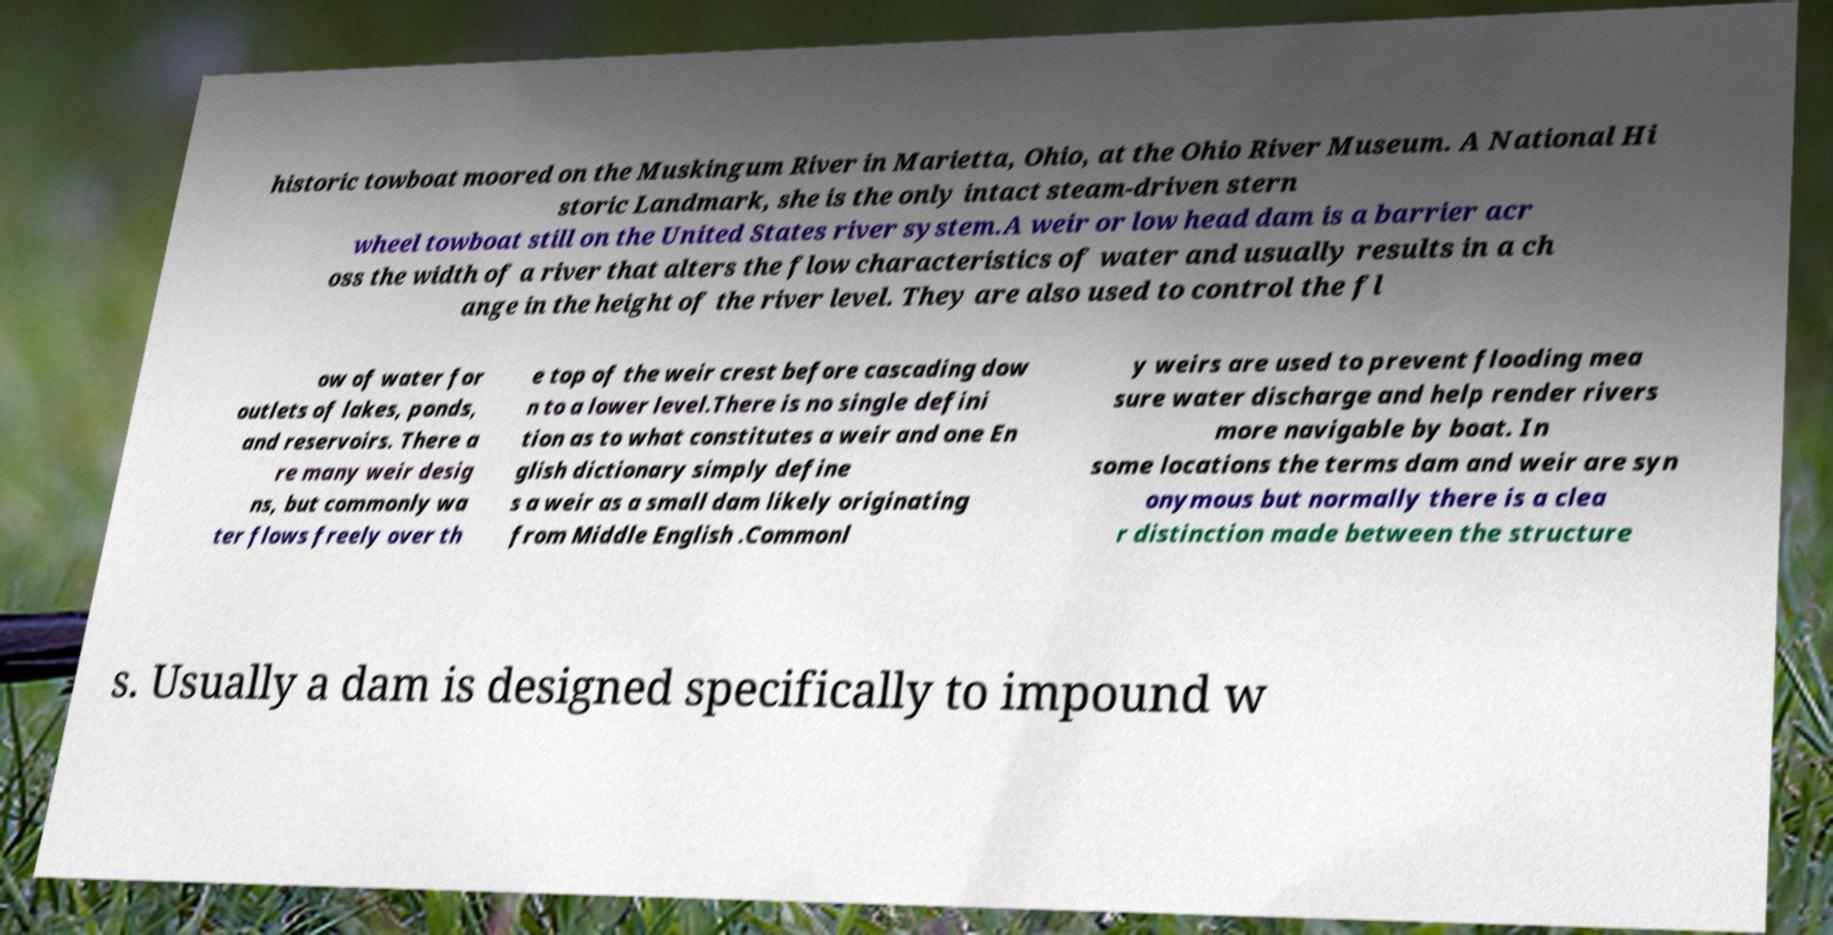I need the written content from this picture converted into text. Can you do that? historic towboat moored on the Muskingum River in Marietta, Ohio, at the Ohio River Museum. A National Hi storic Landmark, she is the only intact steam-driven stern wheel towboat still on the United States river system.A weir or low head dam is a barrier acr oss the width of a river that alters the flow characteristics of water and usually results in a ch ange in the height of the river level. They are also used to control the fl ow of water for outlets of lakes, ponds, and reservoirs. There a re many weir desig ns, but commonly wa ter flows freely over th e top of the weir crest before cascading dow n to a lower level.There is no single defini tion as to what constitutes a weir and one En glish dictionary simply define s a weir as a small dam likely originating from Middle English .Commonl y weirs are used to prevent flooding mea sure water discharge and help render rivers more navigable by boat. In some locations the terms dam and weir are syn onymous but normally there is a clea r distinction made between the structure s. Usually a dam is designed specifically to impound w 